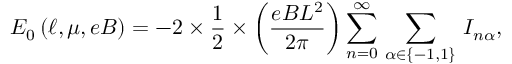<formula> <loc_0><loc_0><loc_500><loc_500>E _ { 0 } \left ( \ell , \mu , e B \right ) = - 2 \times \frac { 1 } { 2 } \times \left ( \frac { e B L ^ { 2 } } { 2 \pi } \right ) \sum _ { n = 0 } ^ { \infty } \, \sum _ { \alpha \in \left \{ - 1 , 1 \right \} } \, I _ { n \alpha } ,</formula> 